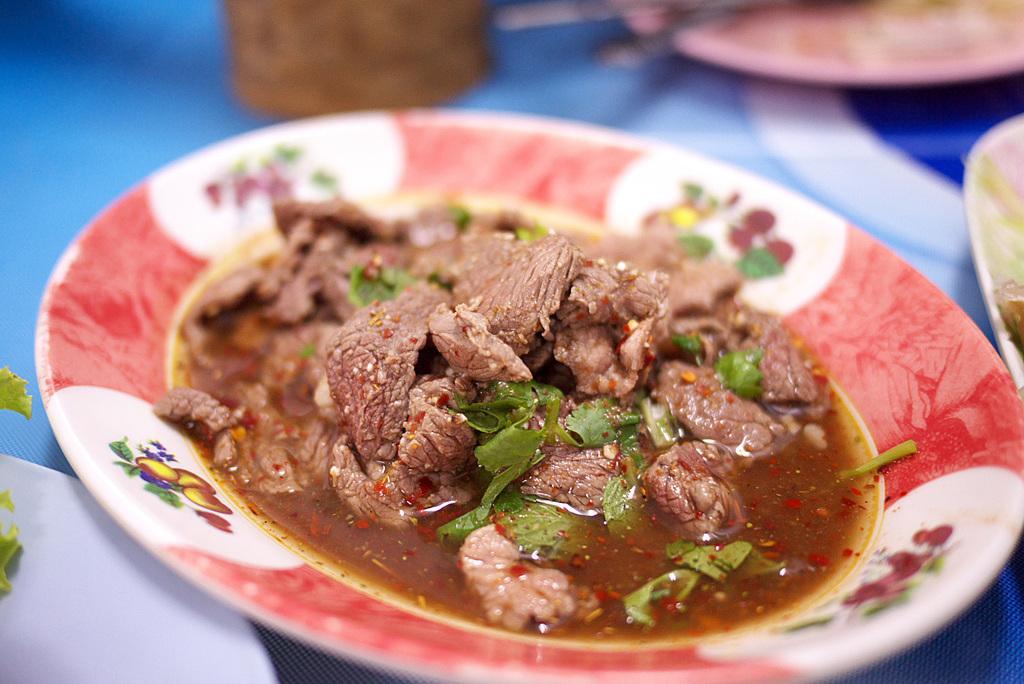Please provide a concise description of this image. In this image we can see food item on a plate. Beside the plate we can see few more plates on a surface. 